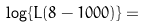<formula> <loc_0><loc_0><loc_500><loc_500>\log \{ L ( 8 - 1 0 0 0 ) \} = \\</formula> 